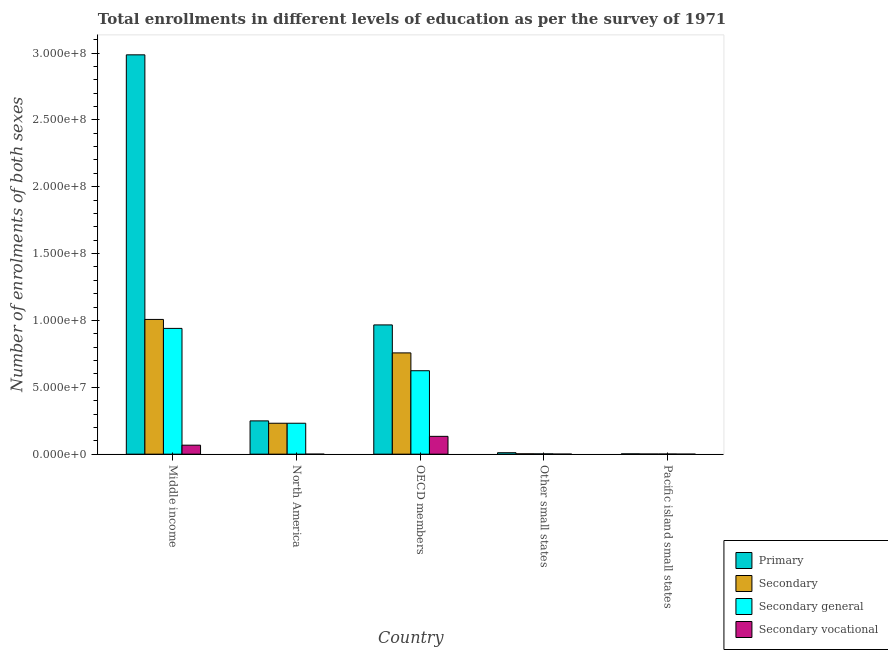How many different coloured bars are there?
Keep it short and to the point. 4. Are the number of bars per tick equal to the number of legend labels?
Your response must be concise. Yes. How many bars are there on the 5th tick from the left?
Provide a short and direct response. 4. What is the label of the 2nd group of bars from the left?
Make the answer very short. North America. What is the number of enrolments in secondary education in Middle income?
Give a very brief answer. 1.01e+08. Across all countries, what is the maximum number of enrolments in primary education?
Your response must be concise. 2.99e+08. Across all countries, what is the minimum number of enrolments in secondary vocational education?
Your answer should be very brief. 424. In which country was the number of enrolments in secondary general education minimum?
Your response must be concise. Pacific island small states. What is the total number of enrolments in secondary vocational education in the graph?
Your answer should be compact. 2.01e+07. What is the difference between the number of enrolments in secondary general education in Middle income and that in OECD members?
Offer a very short reply. 3.17e+07. What is the difference between the number of enrolments in secondary general education in OECD members and the number of enrolments in secondary education in North America?
Offer a very short reply. 3.93e+07. What is the average number of enrolments in secondary education per country?
Give a very brief answer. 4.00e+07. What is the difference between the number of enrolments in secondary vocational education and number of enrolments in secondary general education in Pacific island small states?
Your answer should be very brief. -8.45e+04. What is the ratio of the number of enrolments in secondary education in Middle income to that in Pacific island small states?
Your response must be concise. 1091.75. Is the number of enrolments in secondary general education in Middle income less than that in Other small states?
Offer a terse response. No. Is the difference between the number of enrolments in primary education in OECD members and Pacific island small states greater than the difference between the number of enrolments in secondary vocational education in OECD members and Pacific island small states?
Give a very brief answer. Yes. What is the difference between the highest and the second highest number of enrolments in secondary general education?
Give a very brief answer. 3.17e+07. What is the difference between the highest and the lowest number of enrolments in secondary vocational education?
Your answer should be very brief. 1.33e+07. Is the sum of the number of enrolments in primary education in Other small states and Pacific island small states greater than the maximum number of enrolments in secondary vocational education across all countries?
Offer a very short reply. No. What does the 3rd bar from the left in Middle income represents?
Keep it short and to the point. Secondary general. What does the 2nd bar from the right in OECD members represents?
Keep it short and to the point. Secondary general. How many countries are there in the graph?
Your response must be concise. 5. Are the values on the major ticks of Y-axis written in scientific E-notation?
Your answer should be compact. Yes. How many legend labels are there?
Offer a very short reply. 4. How are the legend labels stacked?
Your response must be concise. Vertical. What is the title of the graph?
Give a very brief answer. Total enrollments in different levels of education as per the survey of 1971. What is the label or title of the Y-axis?
Provide a succinct answer. Number of enrolments of both sexes. What is the Number of enrolments of both sexes of Primary in Middle income?
Keep it short and to the point. 2.99e+08. What is the Number of enrolments of both sexes of Secondary in Middle income?
Offer a very short reply. 1.01e+08. What is the Number of enrolments of both sexes in Secondary general in Middle income?
Offer a very short reply. 9.41e+07. What is the Number of enrolments of both sexes of Secondary vocational in Middle income?
Give a very brief answer. 6.71e+06. What is the Number of enrolments of both sexes of Primary in North America?
Offer a terse response. 2.49e+07. What is the Number of enrolments of both sexes in Secondary in North America?
Keep it short and to the point. 2.31e+07. What is the Number of enrolments of both sexes in Secondary general in North America?
Provide a short and direct response. 2.31e+07. What is the Number of enrolments of both sexes of Secondary vocational in North America?
Offer a very short reply. 424. What is the Number of enrolments of both sexes in Primary in OECD members?
Offer a very short reply. 9.67e+07. What is the Number of enrolments of both sexes in Secondary in OECD members?
Ensure brevity in your answer.  7.57e+07. What is the Number of enrolments of both sexes of Secondary general in OECD members?
Make the answer very short. 6.24e+07. What is the Number of enrolments of both sexes of Secondary vocational in OECD members?
Offer a very short reply. 1.33e+07. What is the Number of enrolments of both sexes in Primary in Other small states?
Provide a short and direct response. 1.09e+06. What is the Number of enrolments of both sexes in Secondary in Other small states?
Offer a terse response. 2.62e+05. What is the Number of enrolments of both sexes in Secondary general in Other small states?
Keep it short and to the point. 2.24e+05. What is the Number of enrolments of both sexes in Secondary vocational in Other small states?
Your answer should be compact. 3.88e+04. What is the Number of enrolments of both sexes of Primary in Pacific island small states?
Your response must be concise. 2.26e+05. What is the Number of enrolments of both sexes of Secondary in Pacific island small states?
Your answer should be compact. 9.23e+04. What is the Number of enrolments of both sexes of Secondary general in Pacific island small states?
Offer a very short reply. 8.84e+04. What is the Number of enrolments of both sexes of Secondary vocational in Pacific island small states?
Provide a short and direct response. 3881.18. Across all countries, what is the maximum Number of enrolments of both sexes of Primary?
Your answer should be very brief. 2.99e+08. Across all countries, what is the maximum Number of enrolments of both sexes in Secondary?
Give a very brief answer. 1.01e+08. Across all countries, what is the maximum Number of enrolments of both sexes in Secondary general?
Your answer should be compact. 9.41e+07. Across all countries, what is the maximum Number of enrolments of both sexes in Secondary vocational?
Keep it short and to the point. 1.33e+07. Across all countries, what is the minimum Number of enrolments of both sexes of Primary?
Your answer should be very brief. 2.26e+05. Across all countries, what is the minimum Number of enrolments of both sexes of Secondary?
Offer a very short reply. 9.23e+04. Across all countries, what is the minimum Number of enrolments of both sexes in Secondary general?
Keep it short and to the point. 8.84e+04. Across all countries, what is the minimum Number of enrolments of both sexes in Secondary vocational?
Ensure brevity in your answer.  424. What is the total Number of enrolments of both sexes in Primary in the graph?
Give a very brief answer. 4.21e+08. What is the total Number of enrolments of both sexes in Secondary in the graph?
Give a very brief answer. 2.00e+08. What is the total Number of enrolments of both sexes of Secondary general in the graph?
Give a very brief answer. 1.80e+08. What is the total Number of enrolments of both sexes in Secondary vocational in the graph?
Your answer should be compact. 2.01e+07. What is the difference between the Number of enrolments of both sexes of Primary in Middle income and that in North America?
Offer a very short reply. 2.74e+08. What is the difference between the Number of enrolments of both sexes of Secondary in Middle income and that in North America?
Make the answer very short. 7.76e+07. What is the difference between the Number of enrolments of both sexes in Secondary general in Middle income and that in North America?
Provide a succinct answer. 7.09e+07. What is the difference between the Number of enrolments of both sexes of Secondary vocational in Middle income and that in North America?
Provide a succinct answer. 6.71e+06. What is the difference between the Number of enrolments of both sexes of Primary in Middle income and that in OECD members?
Offer a terse response. 2.02e+08. What is the difference between the Number of enrolments of both sexes in Secondary in Middle income and that in OECD members?
Your response must be concise. 2.50e+07. What is the difference between the Number of enrolments of both sexes of Secondary general in Middle income and that in OECD members?
Provide a succinct answer. 3.17e+07. What is the difference between the Number of enrolments of both sexes in Secondary vocational in Middle income and that in OECD members?
Provide a short and direct response. -6.61e+06. What is the difference between the Number of enrolments of both sexes in Primary in Middle income and that in Other small states?
Provide a short and direct response. 2.98e+08. What is the difference between the Number of enrolments of both sexes of Secondary in Middle income and that in Other small states?
Ensure brevity in your answer.  1.01e+08. What is the difference between the Number of enrolments of both sexes in Secondary general in Middle income and that in Other small states?
Your answer should be very brief. 9.38e+07. What is the difference between the Number of enrolments of both sexes of Secondary vocational in Middle income and that in Other small states?
Your answer should be very brief. 6.68e+06. What is the difference between the Number of enrolments of both sexes of Primary in Middle income and that in Pacific island small states?
Your answer should be compact. 2.98e+08. What is the difference between the Number of enrolments of both sexes of Secondary in Middle income and that in Pacific island small states?
Give a very brief answer. 1.01e+08. What is the difference between the Number of enrolments of both sexes of Secondary general in Middle income and that in Pacific island small states?
Provide a succinct answer. 9.40e+07. What is the difference between the Number of enrolments of both sexes of Secondary vocational in Middle income and that in Pacific island small states?
Your answer should be compact. 6.71e+06. What is the difference between the Number of enrolments of both sexes in Primary in North America and that in OECD members?
Your answer should be compact. -7.18e+07. What is the difference between the Number of enrolments of both sexes of Secondary in North America and that in OECD members?
Offer a very short reply. -5.26e+07. What is the difference between the Number of enrolments of both sexes of Secondary general in North America and that in OECD members?
Give a very brief answer. -3.93e+07. What is the difference between the Number of enrolments of both sexes of Secondary vocational in North America and that in OECD members?
Offer a terse response. -1.33e+07. What is the difference between the Number of enrolments of both sexes of Primary in North America and that in Other small states?
Provide a short and direct response. 2.38e+07. What is the difference between the Number of enrolments of both sexes in Secondary in North America and that in Other small states?
Keep it short and to the point. 2.29e+07. What is the difference between the Number of enrolments of both sexes in Secondary general in North America and that in Other small states?
Your answer should be very brief. 2.29e+07. What is the difference between the Number of enrolments of both sexes in Secondary vocational in North America and that in Other small states?
Offer a terse response. -3.84e+04. What is the difference between the Number of enrolments of both sexes in Primary in North America and that in Pacific island small states?
Keep it short and to the point. 2.47e+07. What is the difference between the Number of enrolments of both sexes in Secondary in North America and that in Pacific island small states?
Make the answer very short. 2.30e+07. What is the difference between the Number of enrolments of both sexes in Secondary general in North America and that in Pacific island small states?
Give a very brief answer. 2.30e+07. What is the difference between the Number of enrolments of both sexes in Secondary vocational in North America and that in Pacific island small states?
Provide a short and direct response. -3457.18. What is the difference between the Number of enrolments of both sexes of Primary in OECD members and that in Other small states?
Your answer should be compact. 9.56e+07. What is the difference between the Number of enrolments of both sexes of Secondary in OECD members and that in Other small states?
Provide a short and direct response. 7.55e+07. What is the difference between the Number of enrolments of both sexes of Secondary general in OECD members and that in Other small states?
Offer a very short reply. 6.22e+07. What is the difference between the Number of enrolments of both sexes in Secondary vocational in OECD members and that in Other small states?
Ensure brevity in your answer.  1.33e+07. What is the difference between the Number of enrolments of both sexes in Primary in OECD members and that in Pacific island small states?
Your answer should be very brief. 9.64e+07. What is the difference between the Number of enrolments of both sexes in Secondary in OECD members and that in Pacific island small states?
Your response must be concise. 7.56e+07. What is the difference between the Number of enrolments of both sexes in Secondary general in OECD members and that in Pacific island small states?
Provide a succinct answer. 6.23e+07. What is the difference between the Number of enrolments of both sexes of Secondary vocational in OECD members and that in Pacific island small states?
Keep it short and to the point. 1.33e+07. What is the difference between the Number of enrolments of both sexes in Primary in Other small states and that in Pacific island small states?
Provide a short and direct response. 8.63e+05. What is the difference between the Number of enrolments of both sexes in Secondary in Other small states and that in Pacific island small states?
Provide a succinct answer. 1.70e+05. What is the difference between the Number of enrolments of both sexes of Secondary general in Other small states and that in Pacific island small states?
Keep it short and to the point. 1.35e+05. What is the difference between the Number of enrolments of both sexes in Secondary vocational in Other small states and that in Pacific island small states?
Offer a terse response. 3.49e+04. What is the difference between the Number of enrolments of both sexes in Primary in Middle income and the Number of enrolments of both sexes in Secondary in North America?
Your response must be concise. 2.76e+08. What is the difference between the Number of enrolments of both sexes of Primary in Middle income and the Number of enrolments of both sexes of Secondary general in North America?
Keep it short and to the point. 2.76e+08. What is the difference between the Number of enrolments of both sexes in Primary in Middle income and the Number of enrolments of both sexes in Secondary vocational in North America?
Your answer should be compact. 2.99e+08. What is the difference between the Number of enrolments of both sexes of Secondary in Middle income and the Number of enrolments of both sexes of Secondary general in North America?
Offer a terse response. 7.76e+07. What is the difference between the Number of enrolments of both sexes of Secondary in Middle income and the Number of enrolments of both sexes of Secondary vocational in North America?
Offer a very short reply. 1.01e+08. What is the difference between the Number of enrolments of both sexes in Secondary general in Middle income and the Number of enrolments of both sexes in Secondary vocational in North America?
Provide a short and direct response. 9.41e+07. What is the difference between the Number of enrolments of both sexes of Primary in Middle income and the Number of enrolments of both sexes of Secondary in OECD members?
Provide a succinct answer. 2.23e+08. What is the difference between the Number of enrolments of both sexes in Primary in Middle income and the Number of enrolments of both sexes in Secondary general in OECD members?
Provide a short and direct response. 2.36e+08. What is the difference between the Number of enrolments of both sexes of Primary in Middle income and the Number of enrolments of both sexes of Secondary vocational in OECD members?
Your answer should be compact. 2.85e+08. What is the difference between the Number of enrolments of both sexes of Secondary in Middle income and the Number of enrolments of both sexes of Secondary general in OECD members?
Your response must be concise. 3.84e+07. What is the difference between the Number of enrolments of both sexes in Secondary in Middle income and the Number of enrolments of both sexes in Secondary vocational in OECD members?
Your response must be concise. 8.74e+07. What is the difference between the Number of enrolments of both sexes in Secondary general in Middle income and the Number of enrolments of both sexes in Secondary vocational in OECD members?
Your answer should be very brief. 8.07e+07. What is the difference between the Number of enrolments of both sexes of Primary in Middle income and the Number of enrolments of both sexes of Secondary in Other small states?
Offer a very short reply. 2.98e+08. What is the difference between the Number of enrolments of both sexes in Primary in Middle income and the Number of enrolments of both sexes in Secondary general in Other small states?
Keep it short and to the point. 2.98e+08. What is the difference between the Number of enrolments of both sexes in Primary in Middle income and the Number of enrolments of both sexes in Secondary vocational in Other small states?
Your answer should be very brief. 2.99e+08. What is the difference between the Number of enrolments of both sexes in Secondary in Middle income and the Number of enrolments of both sexes in Secondary general in Other small states?
Provide a succinct answer. 1.01e+08. What is the difference between the Number of enrolments of both sexes in Secondary in Middle income and the Number of enrolments of both sexes in Secondary vocational in Other small states?
Provide a short and direct response. 1.01e+08. What is the difference between the Number of enrolments of both sexes in Secondary general in Middle income and the Number of enrolments of both sexes in Secondary vocational in Other small states?
Ensure brevity in your answer.  9.40e+07. What is the difference between the Number of enrolments of both sexes of Primary in Middle income and the Number of enrolments of both sexes of Secondary in Pacific island small states?
Your answer should be very brief. 2.99e+08. What is the difference between the Number of enrolments of both sexes in Primary in Middle income and the Number of enrolments of both sexes in Secondary general in Pacific island small states?
Provide a succinct answer. 2.99e+08. What is the difference between the Number of enrolments of both sexes in Primary in Middle income and the Number of enrolments of both sexes in Secondary vocational in Pacific island small states?
Give a very brief answer. 2.99e+08. What is the difference between the Number of enrolments of both sexes of Secondary in Middle income and the Number of enrolments of both sexes of Secondary general in Pacific island small states?
Give a very brief answer. 1.01e+08. What is the difference between the Number of enrolments of both sexes of Secondary in Middle income and the Number of enrolments of both sexes of Secondary vocational in Pacific island small states?
Ensure brevity in your answer.  1.01e+08. What is the difference between the Number of enrolments of both sexes in Secondary general in Middle income and the Number of enrolments of both sexes in Secondary vocational in Pacific island small states?
Offer a very short reply. 9.40e+07. What is the difference between the Number of enrolments of both sexes in Primary in North America and the Number of enrolments of both sexes in Secondary in OECD members?
Make the answer very short. -5.08e+07. What is the difference between the Number of enrolments of both sexes of Primary in North America and the Number of enrolments of both sexes of Secondary general in OECD members?
Your answer should be very brief. -3.75e+07. What is the difference between the Number of enrolments of both sexes in Primary in North America and the Number of enrolments of both sexes in Secondary vocational in OECD members?
Ensure brevity in your answer.  1.16e+07. What is the difference between the Number of enrolments of both sexes in Secondary in North America and the Number of enrolments of both sexes in Secondary general in OECD members?
Ensure brevity in your answer.  -3.93e+07. What is the difference between the Number of enrolments of both sexes of Secondary in North America and the Number of enrolments of both sexes of Secondary vocational in OECD members?
Keep it short and to the point. 9.80e+06. What is the difference between the Number of enrolments of both sexes in Secondary general in North America and the Number of enrolments of both sexes in Secondary vocational in OECD members?
Make the answer very short. 9.80e+06. What is the difference between the Number of enrolments of both sexes of Primary in North America and the Number of enrolments of both sexes of Secondary in Other small states?
Your answer should be compact. 2.46e+07. What is the difference between the Number of enrolments of both sexes of Primary in North America and the Number of enrolments of both sexes of Secondary general in Other small states?
Give a very brief answer. 2.47e+07. What is the difference between the Number of enrolments of both sexes in Primary in North America and the Number of enrolments of both sexes in Secondary vocational in Other small states?
Your answer should be compact. 2.49e+07. What is the difference between the Number of enrolments of both sexes in Secondary in North America and the Number of enrolments of both sexes in Secondary general in Other small states?
Keep it short and to the point. 2.29e+07. What is the difference between the Number of enrolments of both sexes in Secondary in North America and the Number of enrolments of both sexes in Secondary vocational in Other small states?
Keep it short and to the point. 2.31e+07. What is the difference between the Number of enrolments of both sexes in Secondary general in North America and the Number of enrolments of both sexes in Secondary vocational in Other small states?
Offer a very short reply. 2.31e+07. What is the difference between the Number of enrolments of both sexes in Primary in North America and the Number of enrolments of both sexes in Secondary in Pacific island small states?
Ensure brevity in your answer.  2.48e+07. What is the difference between the Number of enrolments of both sexes of Primary in North America and the Number of enrolments of both sexes of Secondary general in Pacific island small states?
Ensure brevity in your answer.  2.48e+07. What is the difference between the Number of enrolments of both sexes in Primary in North America and the Number of enrolments of both sexes in Secondary vocational in Pacific island small states?
Your response must be concise. 2.49e+07. What is the difference between the Number of enrolments of both sexes of Secondary in North America and the Number of enrolments of both sexes of Secondary general in Pacific island small states?
Keep it short and to the point. 2.30e+07. What is the difference between the Number of enrolments of both sexes in Secondary in North America and the Number of enrolments of both sexes in Secondary vocational in Pacific island small states?
Offer a terse response. 2.31e+07. What is the difference between the Number of enrolments of both sexes of Secondary general in North America and the Number of enrolments of both sexes of Secondary vocational in Pacific island small states?
Keep it short and to the point. 2.31e+07. What is the difference between the Number of enrolments of both sexes in Primary in OECD members and the Number of enrolments of both sexes in Secondary in Other small states?
Your answer should be very brief. 9.64e+07. What is the difference between the Number of enrolments of both sexes in Primary in OECD members and the Number of enrolments of both sexes in Secondary general in Other small states?
Your answer should be compact. 9.64e+07. What is the difference between the Number of enrolments of both sexes of Primary in OECD members and the Number of enrolments of both sexes of Secondary vocational in Other small states?
Your answer should be very brief. 9.66e+07. What is the difference between the Number of enrolments of both sexes of Secondary in OECD members and the Number of enrolments of both sexes of Secondary general in Other small states?
Your answer should be compact. 7.55e+07. What is the difference between the Number of enrolments of both sexes of Secondary in OECD members and the Number of enrolments of both sexes of Secondary vocational in Other small states?
Offer a very short reply. 7.57e+07. What is the difference between the Number of enrolments of both sexes in Secondary general in OECD members and the Number of enrolments of both sexes in Secondary vocational in Other small states?
Provide a short and direct response. 6.24e+07. What is the difference between the Number of enrolments of both sexes of Primary in OECD members and the Number of enrolments of both sexes of Secondary in Pacific island small states?
Your answer should be very brief. 9.66e+07. What is the difference between the Number of enrolments of both sexes in Primary in OECD members and the Number of enrolments of both sexes in Secondary general in Pacific island small states?
Your answer should be very brief. 9.66e+07. What is the difference between the Number of enrolments of both sexes in Primary in OECD members and the Number of enrolments of both sexes in Secondary vocational in Pacific island small states?
Your answer should be very brief. 9.67e+07. What is the difference between the Number of enrolments of both sexes of Secondary in OECD members and the Number of enrolments of both sexes of Secondary general in Pacific island small states?
Make the answer very short. 7.56e+07. What is the difference between the Number of enrolments of both sexes in Secondary in OECD members and the Number of enrolments of both sexes in Secondary vocational in Pacific island small states?
Provide a short and direct response. 7.57e+07. What is the difference between the Number of enrolments of both sexes of Secondary general in OECD members and the Number of enrolments of both sexes of Secondary vocational in Pacific island small states?
Provide a succinct answer. 6.24e+07. What is the difference between the Number of enrolments of both sexes of Primary in Other small states and the Number of enrolments of both sexes of Secondary in Pacific island small states?
Your answer should be very brief. 9.97e+05. What is the difference between the Number of enrolments of both sexes in Primary in Other small states and the Number of enrolments of both sexes in Secondary general in Pacific island small states?
Provide a short and direct response. 1.00e+06. What is the difference between the Number of enrolments of both sexes in Primary in Other small states and the Number of enrolments of both sexes in Secondary vocational in Pacific island small states?
Offer a terse response. 1.09e+06. What is the difference between the Number of enrolments of both sexes of Secondary in Other small states and the Number of enrolments of both sexes of Secondary general in Pacific island small states?
Provide a short and direct response. 1.74e+05. What is the difference between the Number of enrolments of both sexes of Secondary in Other small states and the Number of enrolments of both sexes of Secondary vocational in Pacific island small states?
Provide a short and direct response. 2.59e+05. What is the difference between the Number of enrolments of both sexes of Secondary general in Other small states and the Number of enrolments of both sexes of Secondary vocational in Pacific island small states?
Offer a terse response. 2.20e+05. What is the average Number of enrolments of both sexes of Primary per country?
Provide a succinct answer. 8.43e+07. What is the average Number of enrolments of both sexes in Secondary per country?
Offer a terse response. 4.00e+07. What is the average Number of enrolments of both sexes of Secondary general per country?
Your answer should be compact. 3.60e+07. What is the average Number of enrolments of both sexes of Secondary vocational per country?
Make the answer very short. 4.02e+06. What is the difference between the Number of enrolments of both sexes of Primary and Number of enrolments of both sexes of Secondary in Middle income?
Keep it short and to the point. 1.98e+08. What is the difference between the Number of enrolments of both sexes of Primary and Number of enrolments of both sexes of Secondary general in Middle income?
Make the answer very short. 2.05e+08. What is the difference between the Number of enrolments of both sexes of Primary and Number of enrolments of both sexes of Secondary vocational in Middle income?
Offer a terse response. 2.92e+08. What is the difference between the Number of enrolments of both sexes of Secondary and Number of enrolments of both sexes of Secondary general in Middle income?
Provide a succinct answer. 6.71e+06. What is the difference between the Number of enrolments of both sexes of Secondary and Number of enrolments of both sexes of Secondary vocational in Middle income?
Provide a short and direct response. 9.41e+07. What is the difference between the Number of enrolments of both sexes in Secondary general and Number of enrolments of both sexes in Secondary vocational in Middle income?
Provide a short and direct response. 8.73e+07. What is the difference between the Number of enrolments of both sexes in Primary and Number of enrolments of both sexes in Secondary in North America?
Make the answer very short. 1.77e+06. What is the difference between the Number of enrolments of both sexes in Primary and Number of enrolments of both sexes in Secondary general in North America?
Ensure brevity in your answer.  1.77e+06. What is the difference between the Number of enrolments of both sexes in Primary and Number of enrolments of both sexes in Secondary vocational in North America?
Your answer should be very brief. 2.49e+07. What is the difference between the Number of enrolments of both sexes of Secondary and Number of enrolments of both sexes of Secondary general in North America?
Make the answer very short. 424. What is the difference between the Number of enrolments of both sexes in Secondary and Number of enrolments of both sexes in Secondary vocational in North America?
Your response must be concise. 2.31e+07. What is the difference between the Number of enrolments of both sexes of Secondary general and Number of enrolments of both sexes of Secondary vocational in North America?
Your answer should be very brief. 2.31e+07. What is the difference between the Number of enrolments of both sexes in Primary and Number of enrolments of both sexes in Secondary in OECD members?
Provide a succinct answer. 2.09e+07. What is the difference between the Number of enrolments of both sexes in Primary and Number of enrolments of both sexes in Secondary general in OECD members?
Offer a very short reply. 3.43e+07. What is the difference between the Number of enrolments of both sexes of Primary and Number of enrolments of both sexes of Secondary vocational in OECD members?
Give a very brief answer. 8.33e+07. What is the difference between the Number of enrolments of both sexes of Secondary and Number of enrolments of both sexes of Secondary general in OECD members?
Offer a terse response. 1.33e+07. What is the difference between the Number of enrolments of both sexes of Secondary and Number of enrolments of both sexes of Secondary vocational in OECD members?
Provide a short and direct response. 6.24e+07. What is the difference between the Number of enrolments of both sexes in Secondary general and Number of enrolments of both sexes in Secondary vocational in OECD members?
Offer a terse response. 4.91e+07. What is the difference between the Number of enrolments of both sexes of Primary and Number of enrolments of both sexes of Secondary in Other small states?
Give a very brief answer. 8.27e+05. What is the difference between the Number of enrolments of both sexes of Primary and Number of enrolments of both sexes of Secondary general in Other small states?
Make the answer very short. 8.66e+05. What is the difference between the Number of enrolments of both sexes of Primary and Number of enrolments of both sexes of Secondary vocational in Other small states?
Provide a short and direct response. 1.05e+06. What is the difference between the Number of enrolments of both sexes of Secondary and Number of enrolments of both sexes of Secondary general in Other small states?
Offer a terse response. 3.88e+04. What is the difference between the Number of enrolments of both sexes of Secondary and Number of enrolments of both sexes of Secondary vocational in Other small states?
Your answer should be very brief. 2.24e+05. What is the difference between the Number of enrolments of both sexes of Secondary general and Number of enrolments of both sexes of Secondary vocational in Other small states?
Ensure brevity in your answer.  1.85e+05. What is the difference between the Number of enrolments of both sexes in Primary and Number of enrolments of both sexes in Secondary in Pacific island small states?
Your answer should be compact. 1.34e+05. What is the difference between the Number of enrolments of both sexes of Primary and Number of enrolments of both sexes of Secondary general in Pacific island small states?
Your answer should be very brief. 1.38e+05. What is the difference between the Number of enrolments of both sexes in Primary and Number of enrolments of both sexes in Secondary vocational in Pacific island small states?
Provide a short and direct response. 2.23e+05. What is the difference between the Number of enrolments of both sexes in Secondary and Number of enrolments of both sexes in Secondary general in Pacific island small states?
Give a very brief answer. 3881.18. What is the difference between the Number of enrolments of both sexes of Secondary and Number of enrolments of both sexes of Secondary vocational in Pacific island small states?
Keep it short and to the point. 8.84e+04. What is the difference between the Number of enrolments of both sexes of Secondary general and Number of enrolments of both sexes of Secondary vocational in Pacific island small states?
Keep it short and to the point. 8.45e+04. What is the ratio of the Number of enrolments of both sexes in Primary in Middle income to that in North America?
Your answer should be very brief. 12. What is the ratio of the Number of enrolments of both sexes of Secondary in Middle income to that in North America?
Your answer should be very brief. 4.36. What is the ratio of the Number of enrolments of both sexes of Secondary general in Middle income to that in North America?
Ensure brevity in your answer.  4.07. What is the ratio of the Number of enrolments of both sexes in Secondary vocational in Middle income to that in North America?
Make the answer very short. 1.58e+04. What is the ratio of the Number of enrolments of both sexes in Primary in Middle income to that in OECD members?
Your answer should be compact. 3.09. What is the ratio of the Number of enrolments of both sexes of Secondary in Middle income to that in OECD members?
Offer a terse response. 1.33. What is the ratio of the Number of enrolments of both sexes of Secondary general in Middle income to that in OECD members?
Provide a short and direct response. 1.51. What is the ratio of the Number of enrolments of both sexes of Secondary vocational in Middle income to that in OECD members?
Your answer should be compact. 0.5. What is the ratio of the Number of enrolments of both sexes in Primary in Middle income to that in Other small states?
Ensure brevity in your answer.  274.18. What is the ratio of the Number of enrolments of both sexes in Secondary in Middle income to that in Other small states?
Offer a very short reply. 383.95. What is the ratio of the Number of enrolments of both sexes of Secondary general in Middle income to that in Other small states?
Your answer should be very brief. 420.54. What is the ratio of the Number of enrolments of both sexes of Secondary vocational in Middle income to that in Other small states?
Offer a terse response. 173.03. What is the ratio of the Number of enrolments of both sexes of Primary in Middle income to that in Pacific island small states?
Your answer should be compact. 1318.57. What is the ratio of the Number of enrolments of both sexes in Secondary in Middle income to that in Pacific island small states?
Offer a terse response. 1091.75. What is the ratio of the Number of enrolments of both sexes in Secondary general in Middle income to that in Pacific island small states?
Your response must be concise. 1063.73. What is the ratio of the Number of enrolments of both sexes in Secondary vocational in Middle income to that in Pacific island small states?
Give a very brief answer. 1729.91. What is the ratio of the Number of enrolments of both sexes of Primary in North America to that in OECD members?
Give a very brief answer. 0.26. What is the ratio of the Number of enrolments of both sexes in Secondary in North America to that in OECD members?
Provide a short and direct response. 0.31. What is the ratio of the Number of enrolments of both sexes in Secondary general in North America to that in OECD members?
Your answer should be compact. 0.37. What is the ratio of the Number of enrolments of both sexes in Primary in North America to that in Other small states?
Offer a very short reply. 22.85. What is the ratio of the Number of enrolments of both sexes in Secondary in North America to that in Other small states?
Provide a short and direct response. 88.11. What is the ratio of the Number of enrolments of both sexes in Secondary general in North America to that in Other small states?
Your response must be concise. 103.4. What is the ratio of the Number of enrolments of both sexes in Secondary vocational in North America to that in Other small states?
Provide a succinct answer. 0.01. What is the ratio of the Number of enrolments of both sexes in Primary in North America to that in Pacific island small states?
Offer a very short reply. 109.9. What is the ratio of the Number of enrolments of both sexes of Secondary in North America to that in Pacific island small states?
Ensure brevity in your answer.  250.54. What is the ratio of the Number of enrolments of both sexes in Secondary general in North America to that in Pacific island small states?
Your answer should be very brief. 261.54. What is the ratio of the Number of enrolments of both sexes in Secondary vocational in North America to that in Pacific island small states?
Give a very brief answer. 0.11. What is the ratio of the Number of enrolments of both sexes of Primary in OECD members to that in Other small states?
Keep it short and to the point. 88.74. What is the ratio of the Number of enrolments of both sexes of Secondary in OECD members to that in Other small states?
Your response must be concise. 288.54. What is the ratio of the Number of enrolments of both sexes of Secondary general in OECD members to that in Other small states?
Your response must be concise. 279.02. What is the ratio of the Number of enrolments of both sexes of Secondary vocational in OECD members to that in Other small states?
Offer a terse response. 343.4. What is the ratio of the Number of enrolments of both sexes of Primary in OECD members to that in Pacific island small states?
Provide a succinct answer. 426.77. What is the ratio of the Number of enrolments of both sexes of Secondary in OECD members to that in Pacific island small states?
Offer a terse response. 820.45. What is the ratio of the Number of enrolments of both sexes of Secondary general in OECD members to that in Pacific island small states?
Offer a terse response. 705.76. What is the ratio of the Number of enrolments of both sexes of Secondary vocational in OECD members to that in Pacific island small states?
Provide a succinct answer. 3433.31. What is the ratio of the Number of enrolments of both sexes of Primary in Other small states to that in Pacific island small states?
Ensure brevity in your answer.  4.81. What is the ratio of the Number of enrolments of both sexes in Secondary in Other small states to that in Pacific island small states?
Your answer should be very brief. 2.84. What is the ratio of the Number of enrolments of both sexes of Secondary general in Other small states to that in Pacific island small states?
Your answer should be compact. 2.53. What is the ratio of the Number of enrolments of both sexes of Secondary vocational in Other small states to that in Pacific island small states?
Offer a terse response. 10. What is the difference between the highest and the second highest Number of enrolments of both sexes in Primary?
Offer a very short reply. 2.02e+08. What is the difference between the highest and the second highest Number of enrolments of both sexes of Secondary?
Offer a very short reply. 2.50e+07. What is the difference between the highest and the second highest Number of enrolments of both sexes of Secondary general?
Your answer should be compact. 3.17e+07. What is the difference between the highest and the second highest Number of enrolments of both sexes in Secondary vocational?
Provide a succinct answer. 6.61e+06. What is the difference between the highest and the lowest Number of enrolments of both sexes in Primary?
Your answer should be compact. 2.98e+08. What is the difference between the highest and the lowest Number of enrolments of both sexes of Secondary?
Make the answer very short. 1.01e+08. What is the difference between the highest and the lowest Number of enrolments of both sexes of Secondary general?
Give a very brief answer. 9.40e+07. What is the difference between the highest and the lowest Number of enrolments of both sexes in Secondary vocational?
Your answer should be very brief. 1.33e+07. 